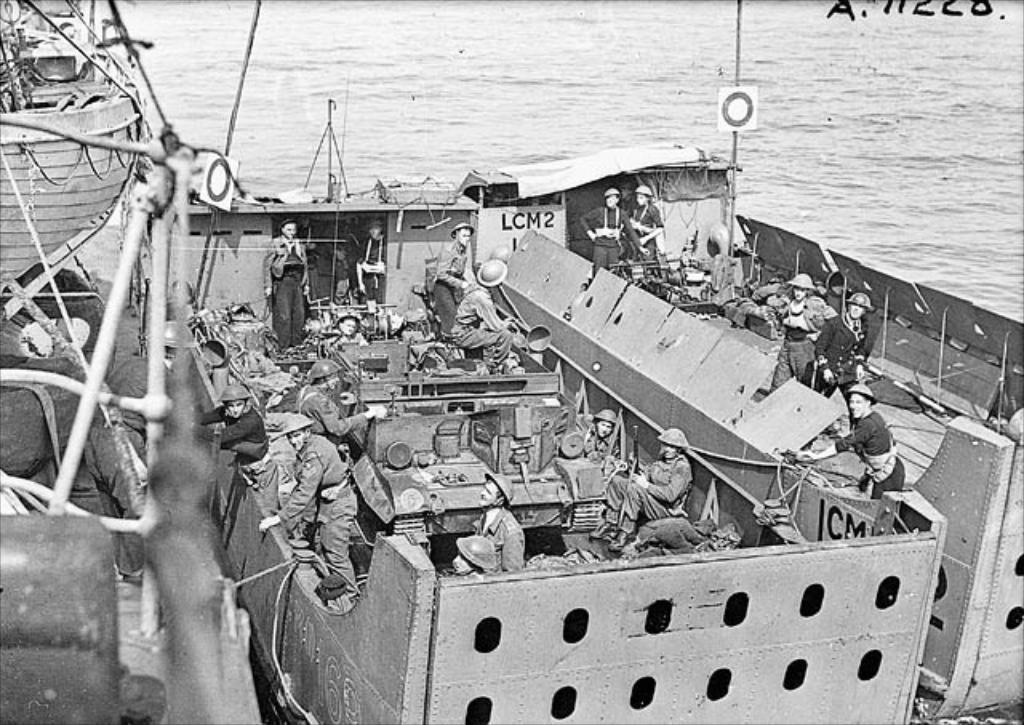What can be seen in the foreground of the image? In the foreground of the image, there are ships, people, and an army tank. What else is present in the foreground of the image? Various objects are also present in the foreground of the image. Can you describe the water body visible at the top of the image? There is a water body visible at the top of the image, but its specific characteristics are not mentioned in the facts. What type of drum is being played by the people in the image? There is no drum present in the image; the people are not shown playing any musical instruments. 